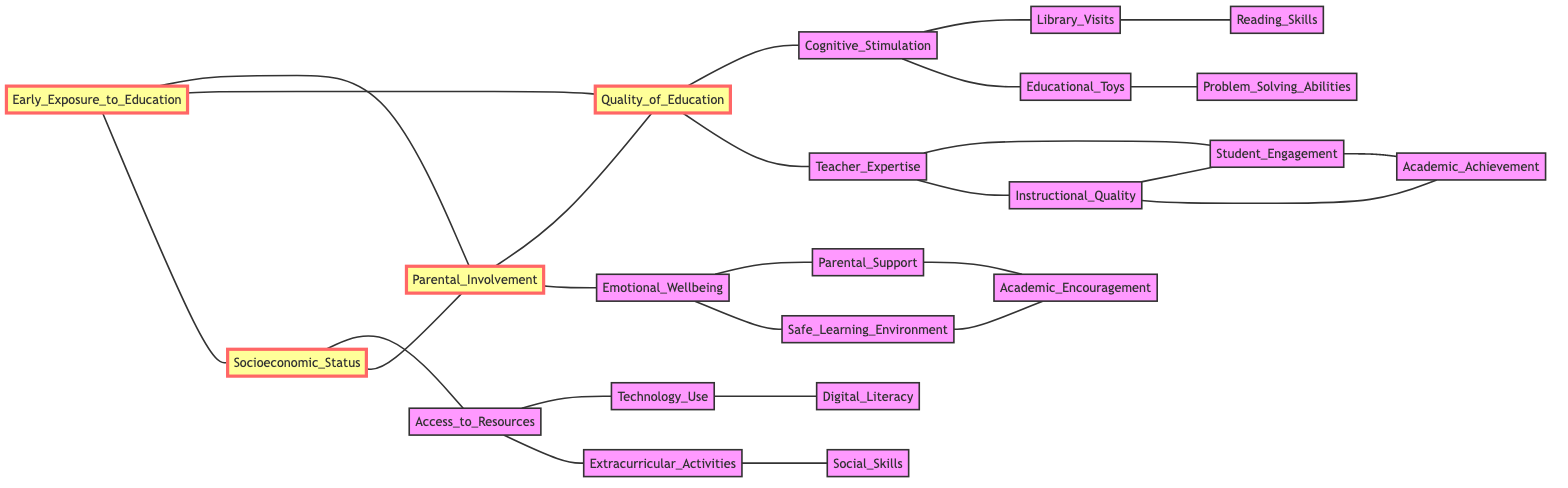What are the three primary influences connected to Early Exposure to Education? Early Exposure to Education has connections to Parental Involvement, Quality of Education, and Socioeconomic Status, as indicated by the edges directly connecting these nodes.
Answer: Parental Involvement, Quality of Education, Socioeconomic Status How many nodes in total are represented in the diagram? The diagram includes a total of 16 distinct nodes, as counted from the provided elements list.
Answer: 16 Which node is connected to both Teacher Expertise and Emotional Wellbeing? By evaluating the connections, it is clear that Parental Involvement connects to both Teacher Expertise and Emotional Wellbeing, thus linking these two nodes.
Answer: Parental Involvement What is the relationship between Cognitive Stimulation and Library Visits? The diagram shows a direct connection between Cognitive Stimulation and Library Visits, indicating they are linked by an edge in the undirected graph.
Answer: Connected What two factors influence Access to Resources? Access to Resources is influenced by Technology Use and Extracurricular Activities, which are the direct connections indicated in the graph.
Answer: Technology Use, Extracurricular Activities Which two nodes are directly linked to Student Engagement? Student Engagement is directly linked to two nodes: Teacher Expertise and Academic Achievement, as shown by the edges connecting them.
Answer: Teacher Expertise, Academic Achievement If a child experiences high Parental Support, which two outcomes are likely to improve? High Parental Support is likely to improve both Emotional Wellbeing and Academic Encouragement, based on the direct connections shown in the diagram.
Answer: Emotional Wellbeing, Academic Encouragement What does the connection between Quality of Education and Cognitive Stimulation indicate? The connection signifies that higher Quality of Education is associated with increased Cognitive Stimulation, demonstrating a direct influence relationship between these two nodes.
Answer: Increased Cognitive Stimulation How many edges are connected to Socioeconomic Status? Socioeconomic Status is associated with three edges: one to Access to Resources and two to Parental Involvement, resulting in a total of three connections.
Answer: 3 